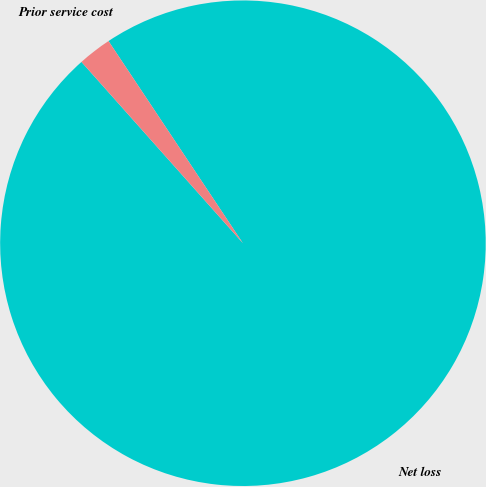<chart> <loc_0><loc_0><loc_500><loc_500><pie_chart><fcel>Net loss<fcel>Prior service cost<nl><fcel>97.76%<fcel>2.24%<nl></chart> 